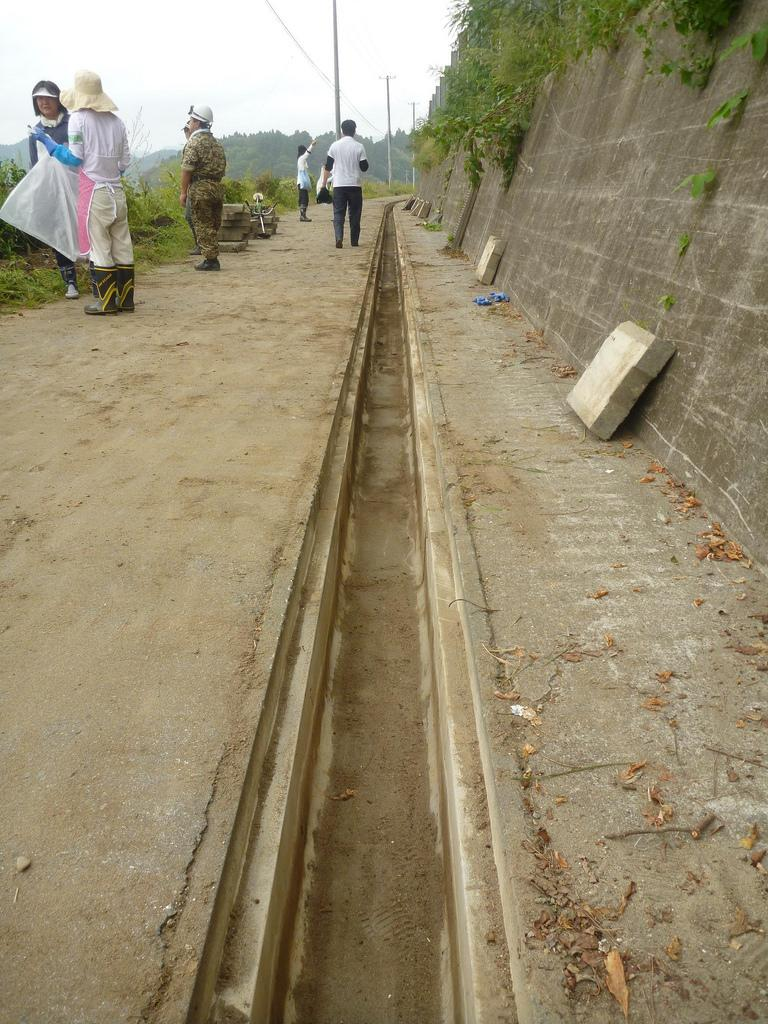What type of structures can be seen in the image? There are walls in the image. What type of vegetation is present in the image? Shredded leaves, creepers, plants, and trees are visible in the image. What is the position of the persons in the image? The persons are on the floor in the image. What other objects can be seen in the image? Poles are present in the image. What part of the natural environment is visible in the image? The sky is visible in the image. What type of flag is being used for business purposes in the image? There is no flag or business activity present in the image. Can you tell me how many pears are visible in the image? There are no pears present in the image. 